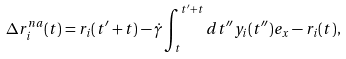Convert formula to latex. <formula><loc_0><loc_0><loc_500><loc_500>\Delta r ^ { n a } _ { i } ( t ) = r _ { i } ( t ^ { \prime } + t ) - \dot { \gamma } \int _ { t } ^ { t ^ { \prime } + t } d t ^ { \prime \prime } y _ { i } ( t ^ { \prime \prime } ) e _ { x } - r _ { i } ( t ) ,</formula> 